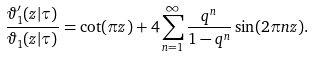Convert formula to latex. <formula><loc_0><loc_0><loc_500><loc_500>\frac { \vartheta _ { 1 } ^ { \prime } ( z | \tau ) } { \vartheta _ { 1 } ( z | \tau ) } = \cot ( \pi z ) + 4 \sum _ { n = 1 } ^ { \infty } \frac { q ^ { n } } { 1 - q ^ { n } } \sin ( 2 \pi n z ) .</formula> 